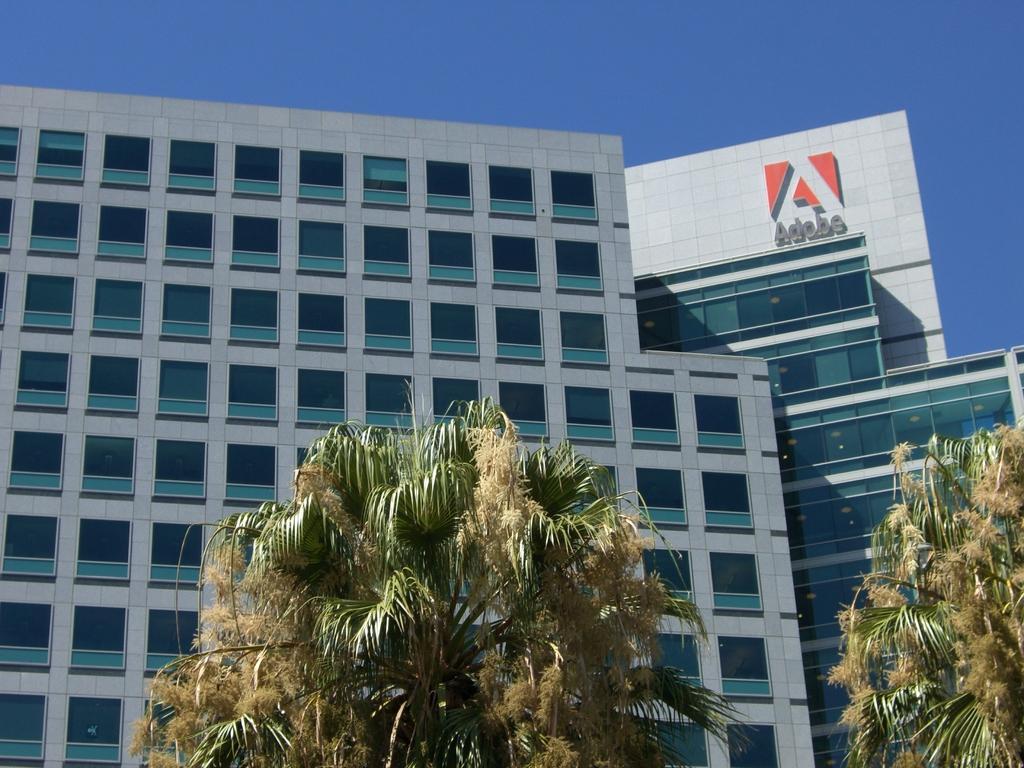Could you give a brief overview of what you see in this image? In this image at the bottom there are trees, and in the background there are buildings and there is text on the building. At the top of the image there is sky. 